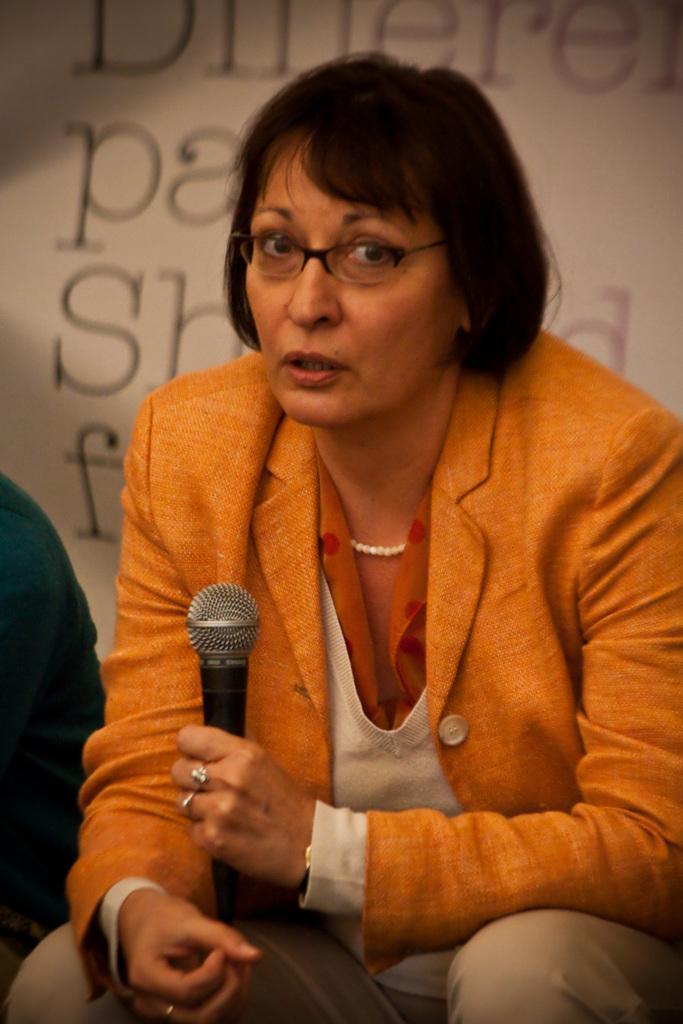How would you summarize this image in a sentence or two? I this image we can see a woman sitting holding a mic. On the backside we can see some text. 